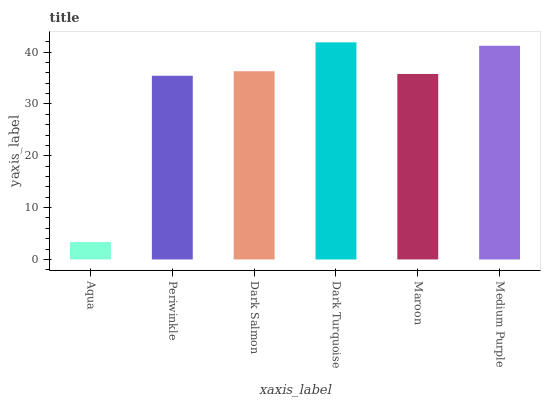Is Aqua the minimum?
Answer yes or no. Yes. Is Dark Turquoise the maximum?
Answer yes or no. Yes. Is Periwinkle the minimum?
Answer yes or no. No. Is Periwinkle the maximum?
Answer yes or no. No. Is Periwinkle greater than Aqua?
Answer yes or no. Yes. Is Aqua less than Periwinkle?
Answer yes or no. Yes. Is Aqua greater than Periwinkle?
Answer yes or no. No. Is Periwinkle less than Aqua?
Answer yes or no. No. Is Dark Salmon the high median?
Answer yes or no. Yes. Is Maroon the low median?
Answer yes or no. Yes. Is Aqua the high median?
Answer yes or no. No. Is Periwinkle the low median?
Answer yes or no. No. 